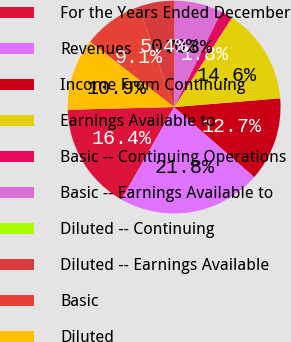<chart> <loc_0><loc_0><loc_500><loc_500><pie_chart><fcel>For the Years Ended December<fcel>Revenues<fcel>Income From Continuing<fcel>Earnings Available to<fcel>Basic -­ Continuing Operations<fcel>Basic -­ Earnings Available to<fcel>Diluted -­ Continuing<fcel>Diluted -­ Earnings Available<fcel>Basic<fcel>Diluted<nl><fcel>16.36%<fcel>21.82%<fcel>12.73%<fcel>14.55%<fcel>1.82%<fcel>7.27%<fcel>0.0%<fcel>5.45%<fcel>9.09%<fcel>10.91%<nl></chart> 